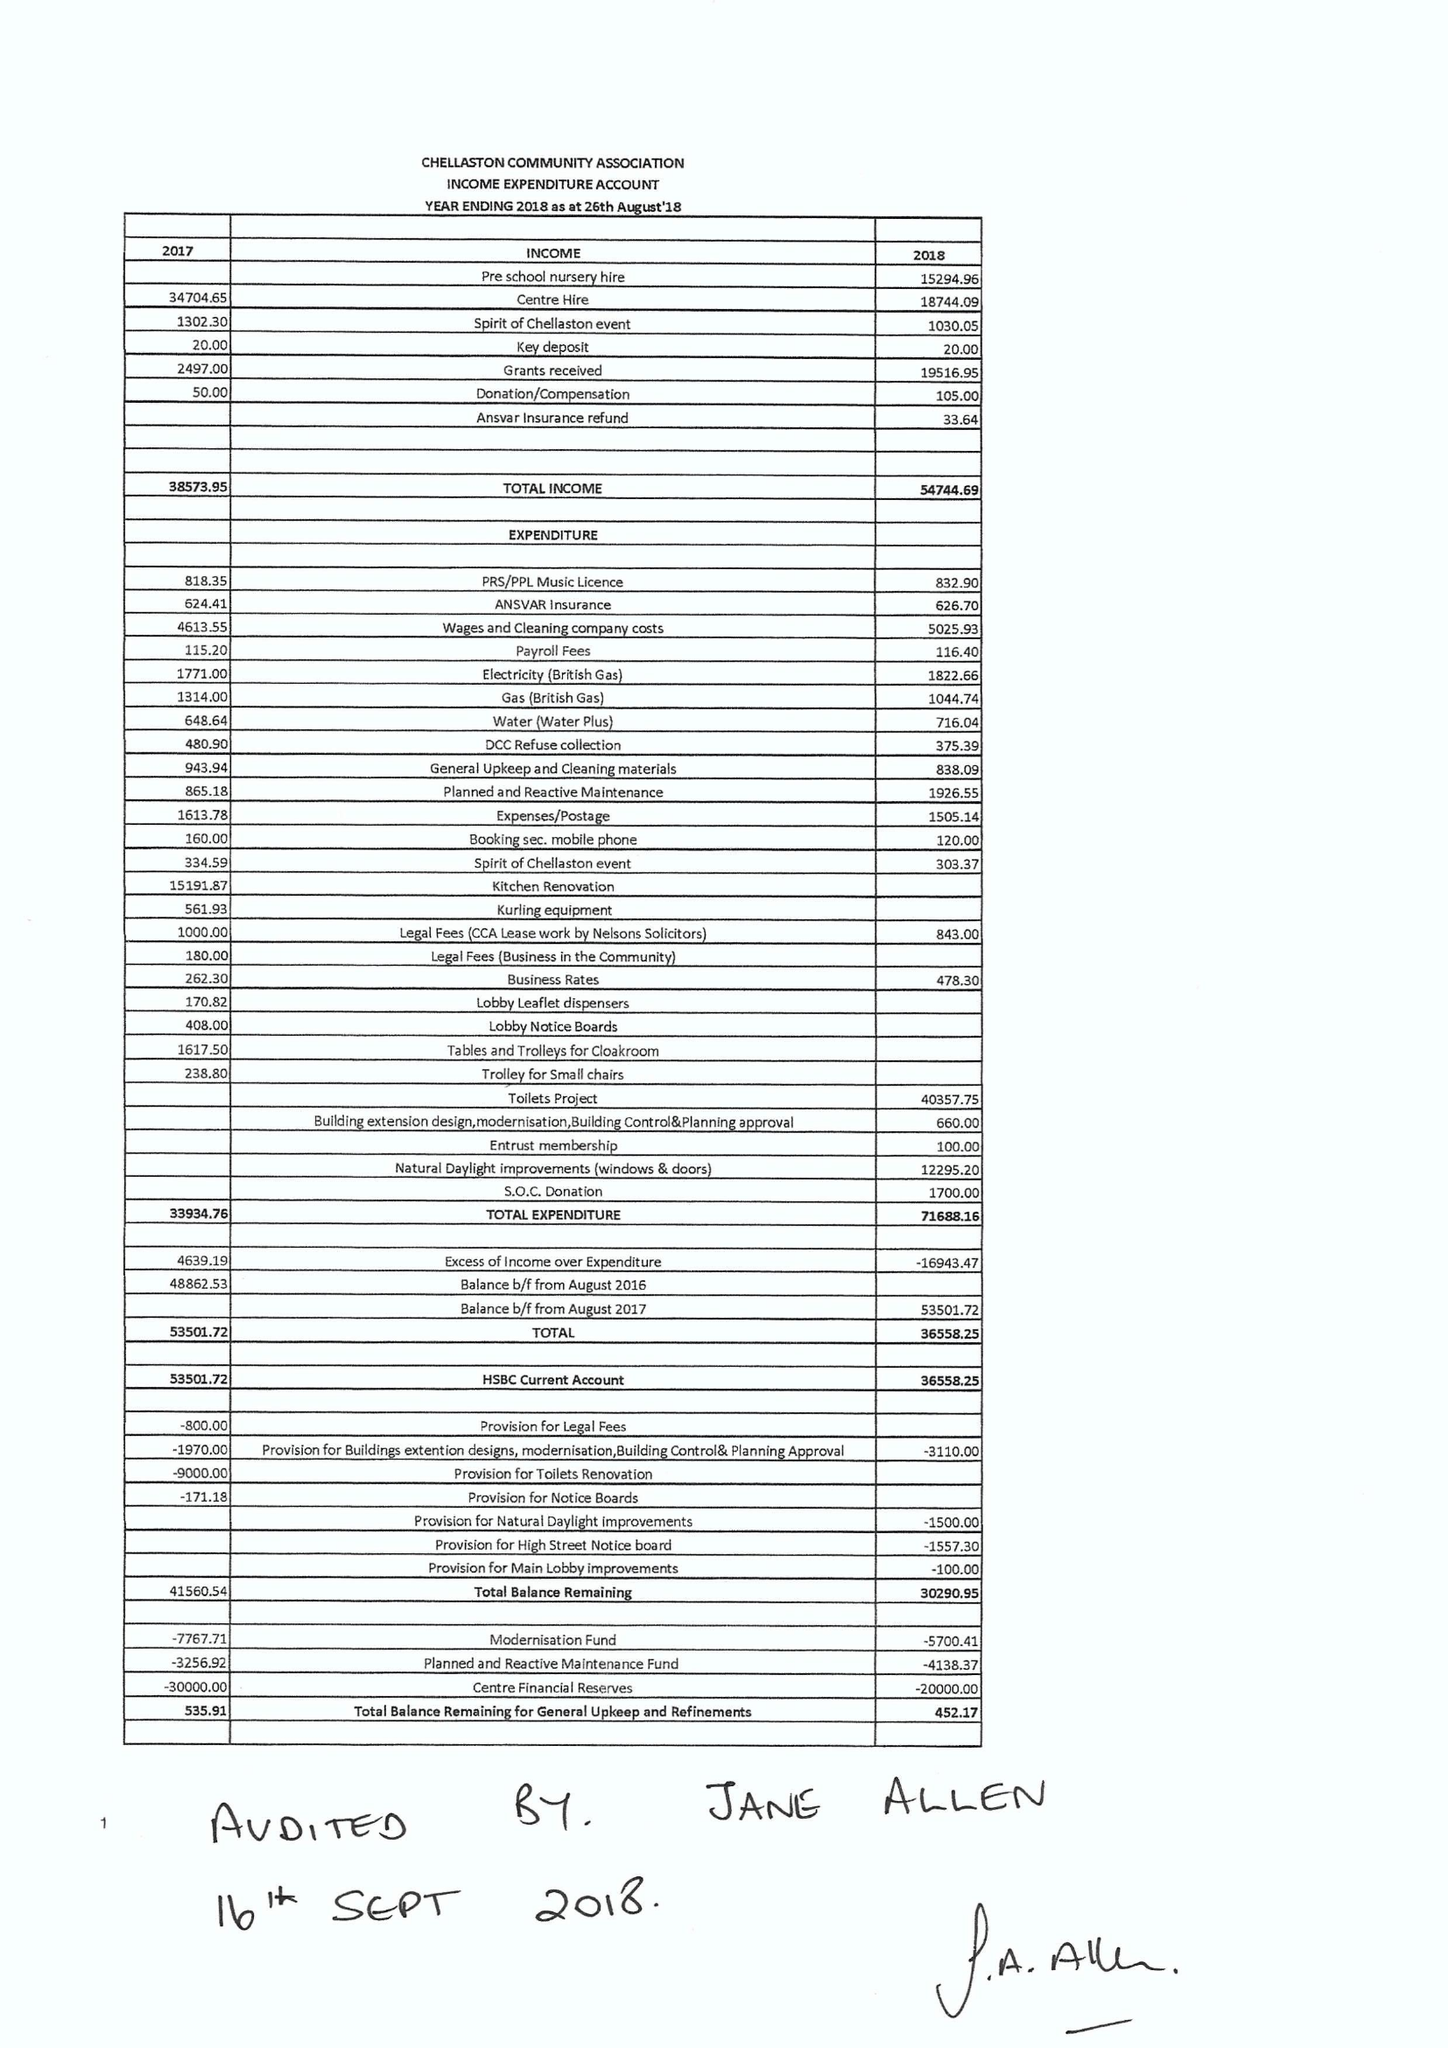What is the value for the charity_number?
Answer the question using a single word or phrase. 1173163 